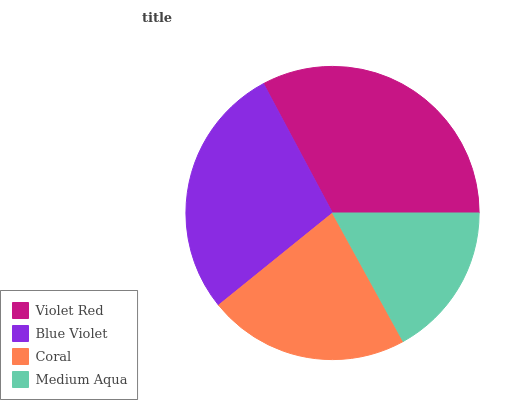Is Medium Aqua the minimum?
Answer yes or no. Yes. Is Violet Red the maximum?
Answer yes or no. Yes. Is Blue Violet the minimum?
Answer yes or no. No. Is Blue Violet the maximum?
Answer yes or no. No. Is Violet Red greater than Blue Violet?
Answer yes or no. Yes. Is Blue Violet less than Violet Red?
Answer yes or no. Yes. Is Blue Violet greater than Violet Red?
Answer yes or no. No. Is Violet Red less than Blue Violet?
Answer yes or no. No. Is Blue Violet the high median?
Answer yes or no. Yes. Is Coral the low median?
Answer yes or no. Yes. Is Violet Red the high median?
Answer yes or no. No. Is Blue Violet the low median?
Answer yes or no. No. 